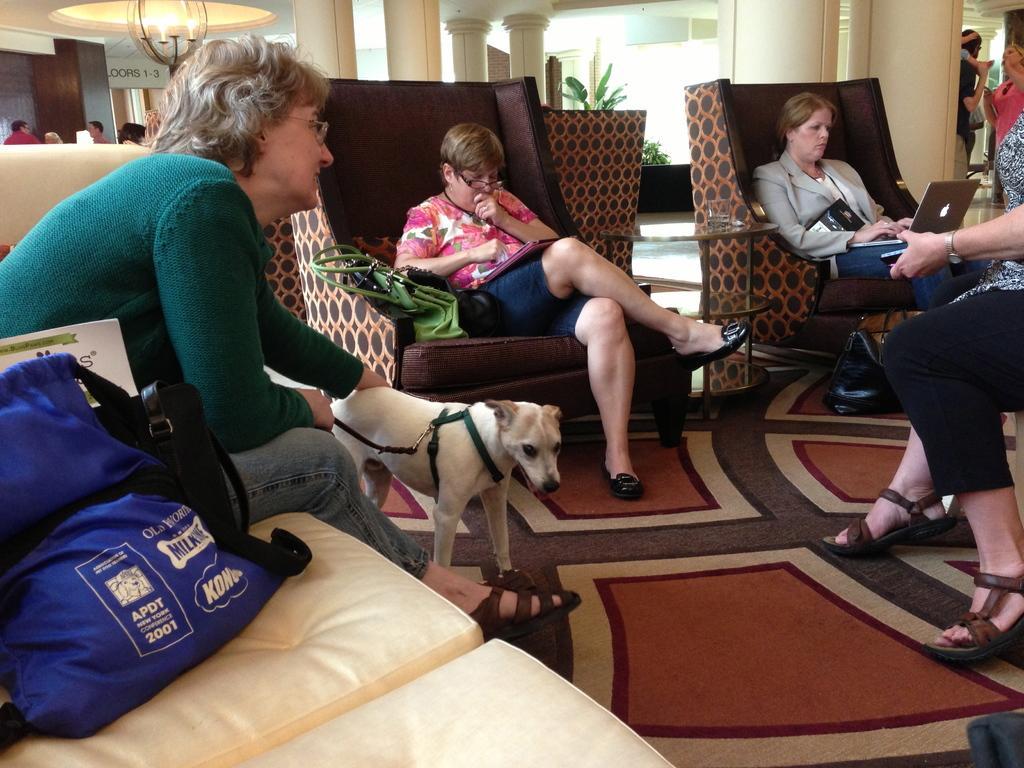Could you give a brief overview of what you see in this image? There are four women sitting on the chairs. These are the bags on the couch,This is the small dog. This is the laptop on the women lap. This is a small glass table with a tumbler on it. Here I can see a black bag placed on the floor. This look like a carpet on the floor. At background I can see people standing at the corners of the image. These are the pillars. Here I can see trees. 